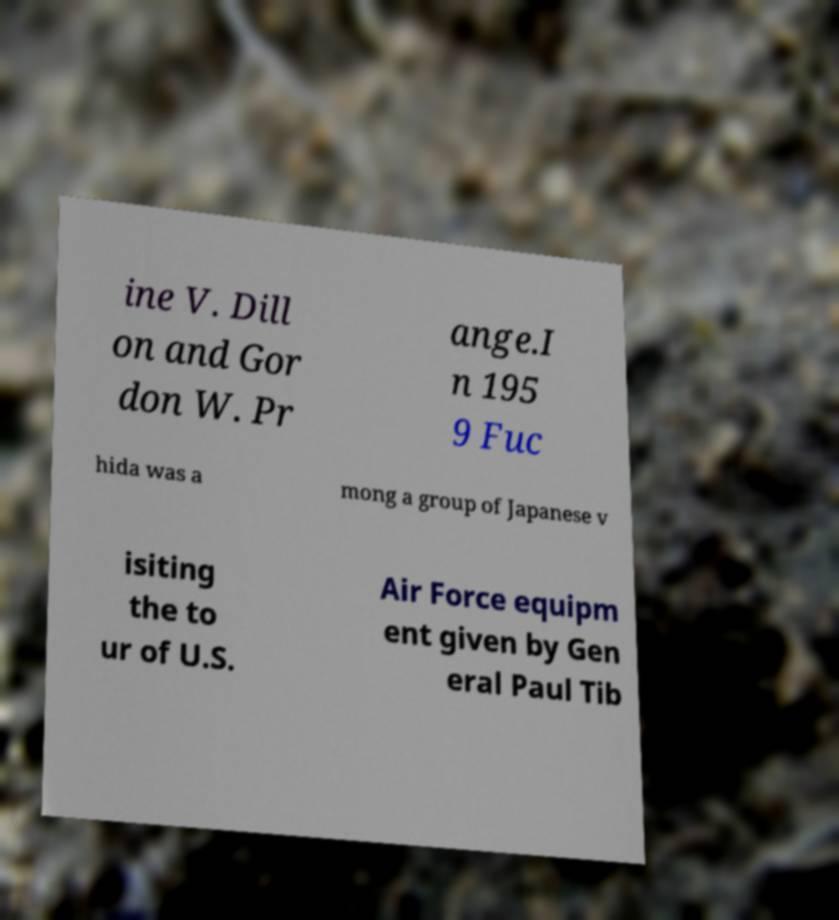Can you accurately transcribe the text from the provided image for me? ine V. Dill on and Gor don W. Pr ange.I n 195 9 Fuc hida was a mong a group of Japanese v isiting the to ur of U.S. Air Force equipm ent given by Gen eral Paul Tib 